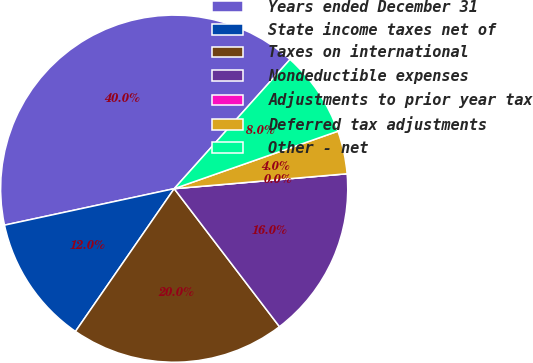Convert chart to OTSL. <chart><loc_0><loc_0><loc_500><loc_500><pie_chart><fcel>Years ended December 31<fcel>State income taxes net of<fcel>Taxes on international<fcel>Nondeductible expenses<fcel>Adjustments to prior year tax<fcel>Deferred tax adjustments<fcel>Other - net<nl><fcel>40.0%<fcel>12.0%<fcel>20.0%<fcel>16.0%<fcel>0.0%<fcel>4.0%<fcel>8.0%<nl></chart> 